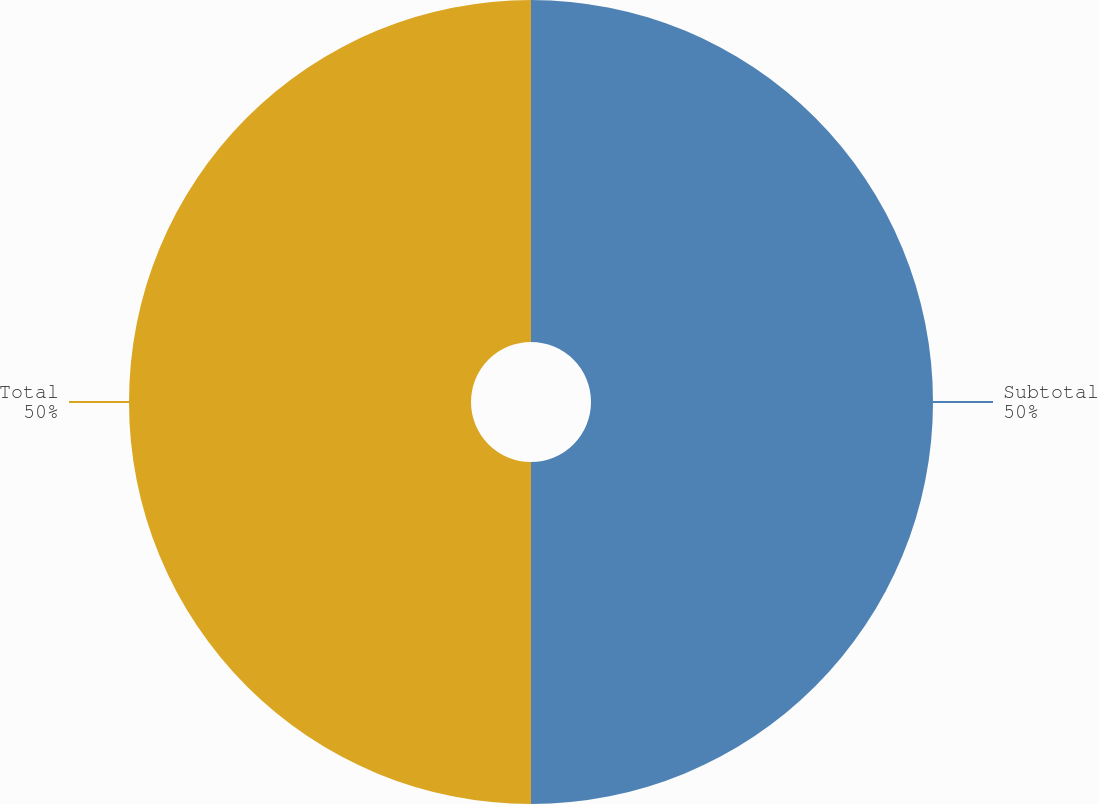<chart> <loc_0><loc_0><loc_500><loc_500><pie_chart><fcel>Subtotal<fcel>Total<nl><fcel>50.0%<fcel>50.0%<nl></chart> 